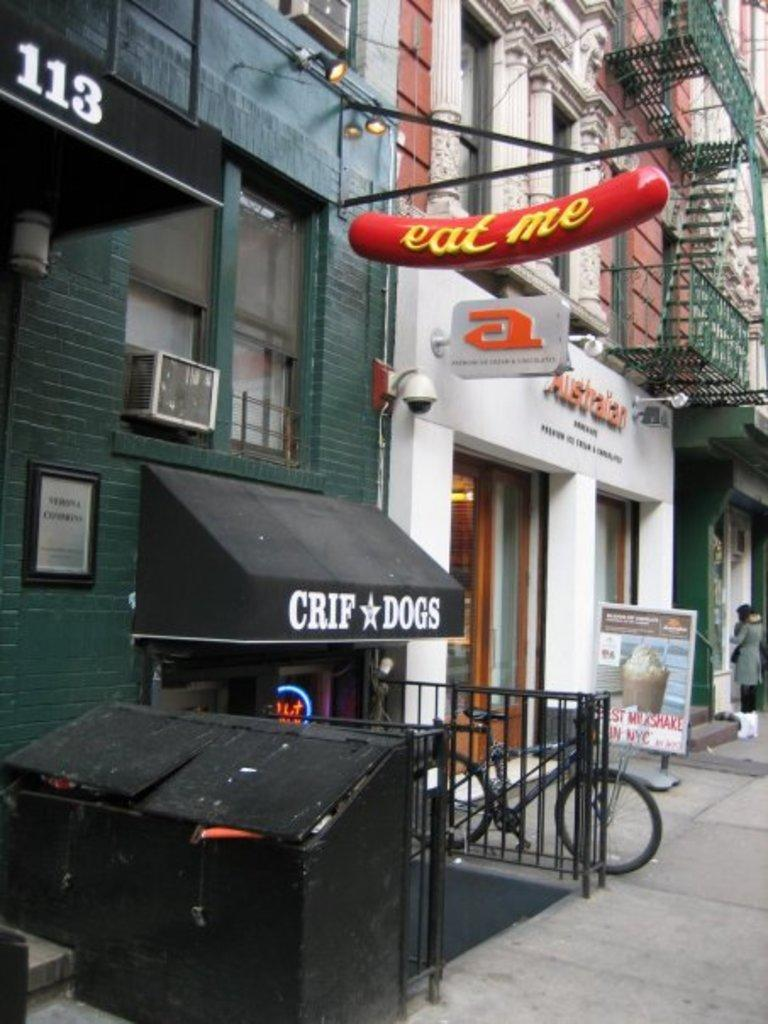What type of structures can be seen in the image? There are buildings in the image. What else is present on the boards in the image? The boards have text in the image. Where is the bicycle located in the image? The bicycle is on the sidewalk in the image. What might be used for disposing of waste in the image? There appears to be a dustbin in the image. What type of bead is used to decorate the buildings in the image? There are no beads present on the buildings in the image. What brand of toothpaste is advertised on the boards in the image? There is no toothpaste advertised on the boards in the image; they only have text. 